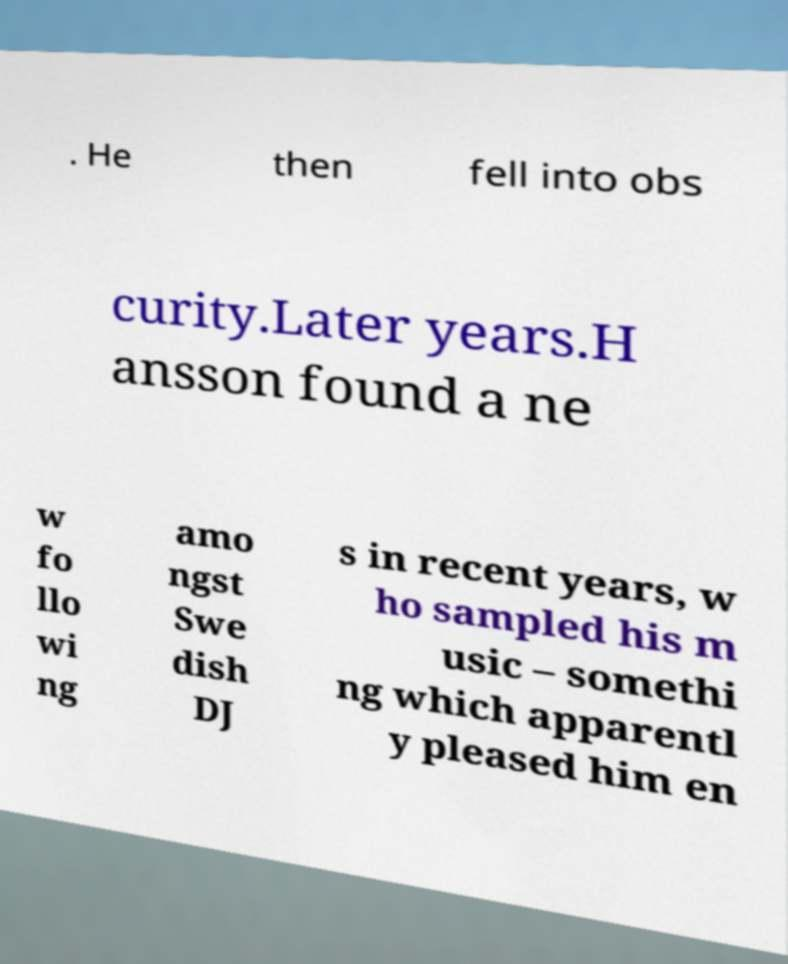Please read and relay the text visible in this image. What does it say? . He then fell into obs curity.Later years.H ansson found a ne w fo llo wi ng amo ngst Swe dish DJ s in recent years, w ho sampled his m usic – somethi ng which apparentl y pleased him en 